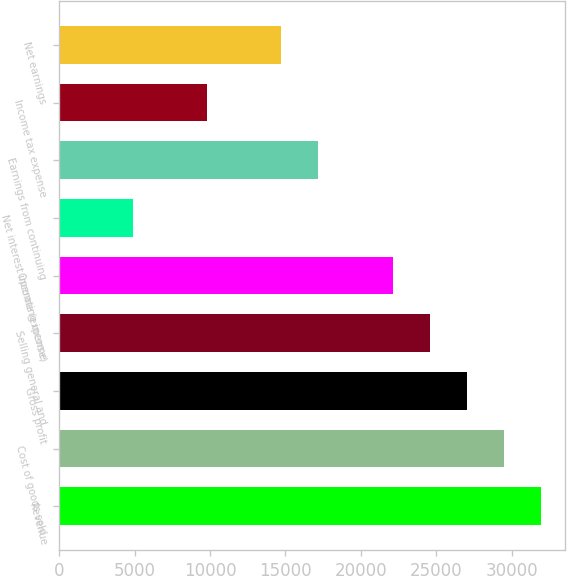Convert chart. <chart><loc_0><loc_0><loc_500><loc_500><bar_chart><fcel>Revenue<fcel>Cost of goods sold<fcel>Gross profit<fcel>Selling general and<fcel>Operating income<fcel>Net interest income (expense)<fcel>Earnings from continuing<fcel>Income tax expense<fcel>Net earnings<nl><fcel>31912<fcel>29457.3<fcel>27002.7<fcel>24548<fcel>22093.4<fcel>4910.74<fcel>17184<fcel>9820.06<fcel>14729.4<nl></chart> 